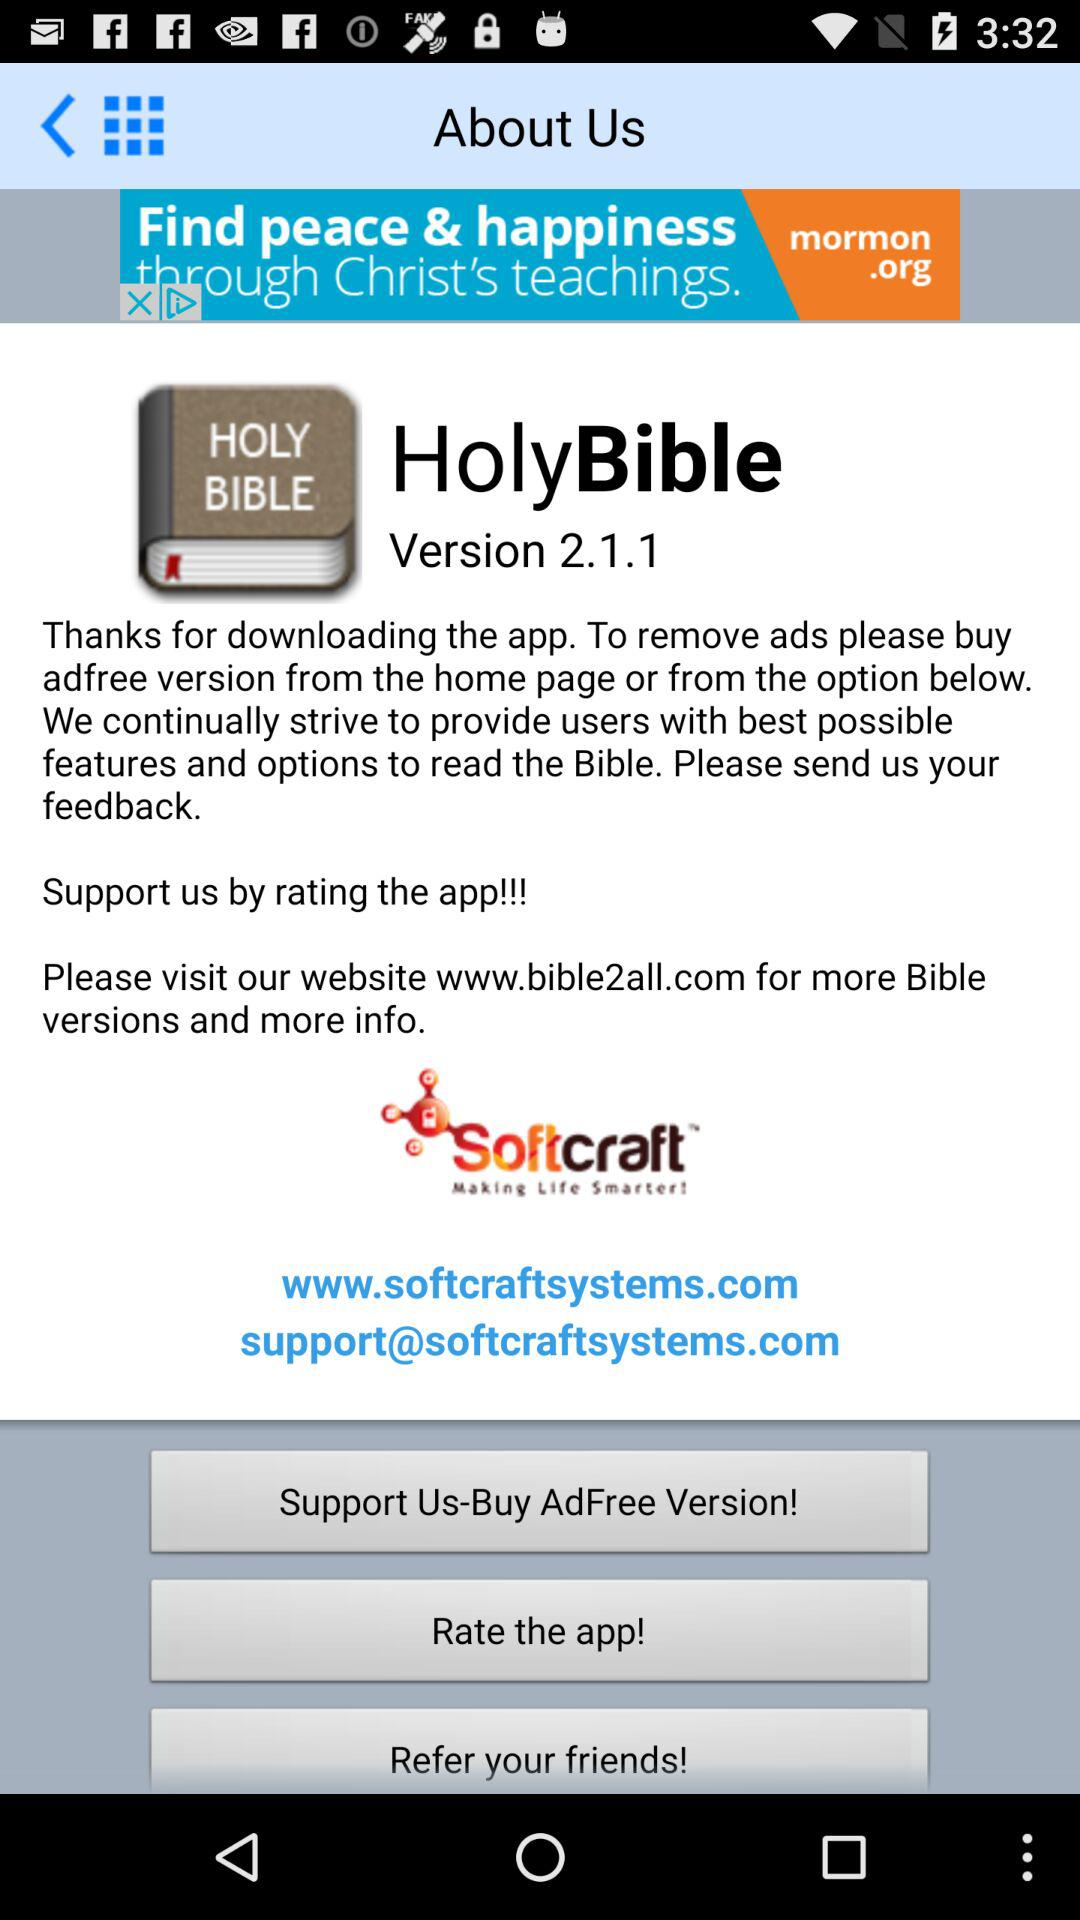What is the version of the application? The version of the application is 2.1.1. 